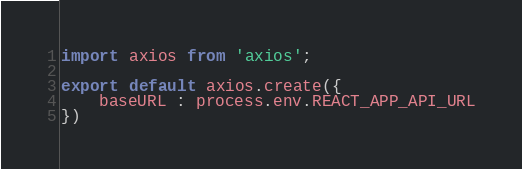<code> <loc_0><loc_0><loc_500><loc_500><_JavaScript_>import axios from 'axios';

export default axios.create({
    baseURL : process.env.REACT_APP_API_URL
})</code> 